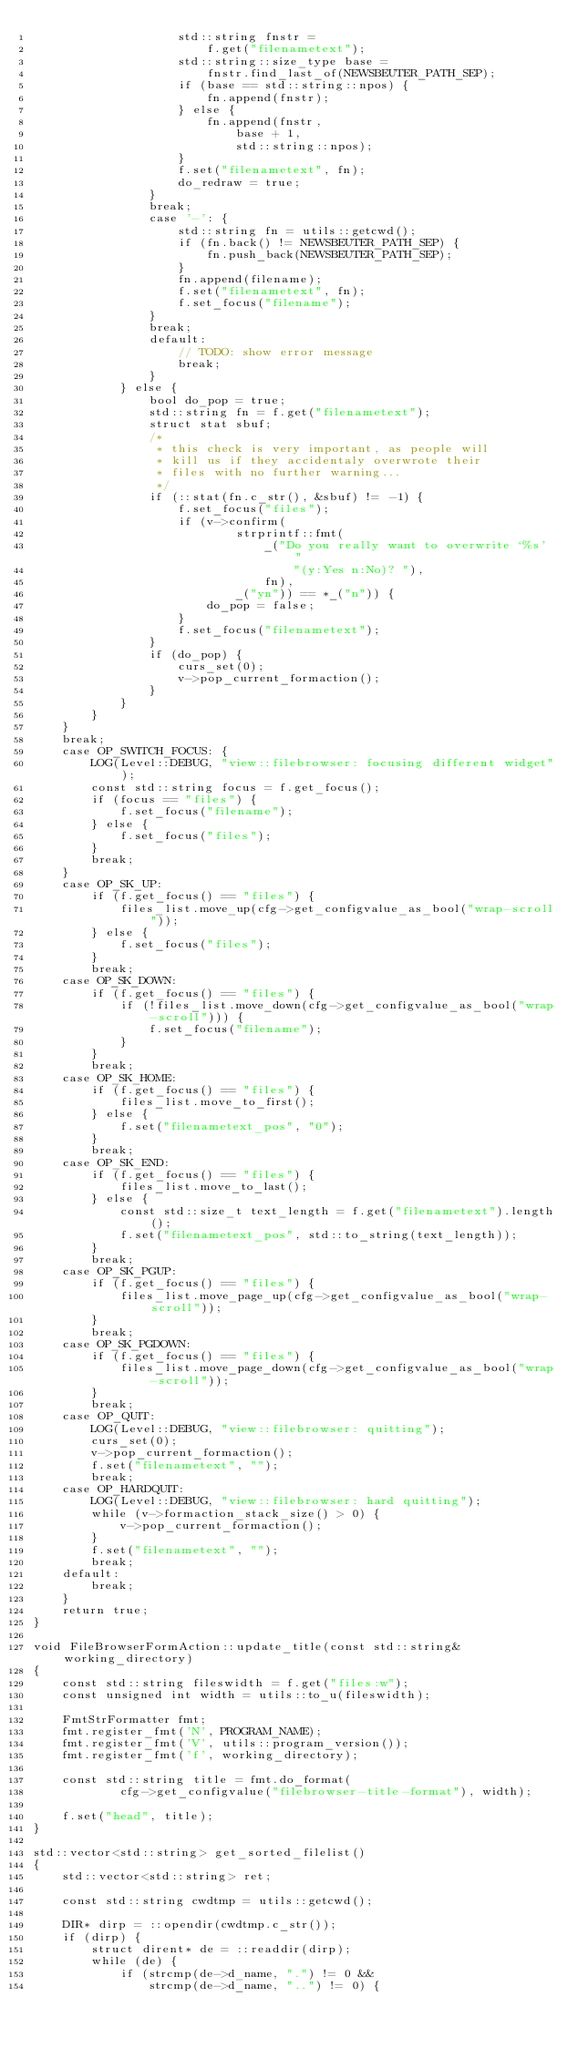<code> <loc_0><loc_0><loc_500><loc_500><_C++_>					std::string fnstr =
						f.get("filenametext");
					std::string::size_type base =
						fnstr.find_last_of(NEWSBEUTER_PATH_SEP);
					if (base == std::string::npos) {
						fn.append(fnstr);
					} else {
						fn.append(fnstr,
							base + 1,
							std::string::npos);
					}
					f.set("filenametext", fn);
					do_redraw = true;
				}
				break;
				case '-': {
					std::string fn = utils::getcwd();
					if (fn.back() != NEWSBEUTER_PATH_SEP) {
						fn.push_back(NEWSBEUTER_PATH_SEP);
					}
					fn.append(filename);
					f.set("filenametext", fn);
					f.set_focus("filename");
				}
				break;
				default:
					// TODO: show error message
					break;
				}
			} else {
				bool do_pop = true;
				std::string fn = f.get("filenametext");
				struct stat sbuf;
				/*
				 * this check is very important, as people will
				 * kill us if they accidentaly overwrote their
				 * files with no further warning...
				 */
				if (::stat(fn.c_str(), &sbuf) != -1) {
					f.set_focus("files");
					if (v->confirm(
							strprintf::fmt(
								_("Do you really want to overwrite `%s' "
									"(y:Yes n:No)? "),
								fn),
							_("yn")) == *_("n")) {
						do_pop = false;
					}
					f.set_focus("filenametext");
				}
				if (do_pop) {
					curs_set(0);
					v->pop_current_formaction();
				}
			}
		}
	}
	break;
	case OP_SWITCH_FOCUS: {
		LOG(Level::DEBUG, "view::filebrowser: focusing different widget");
		const std::string focus = f.get_focus();
		if (focus == "files") {
			f.set_focus("filename");
		} else {
			f.set_focus("files");
		}
		break;
	}
	case OP_SK_UP:
		if (f.get_focus() == "files") {
			files_list.move_up(cfg->get_configvalue_as_bool("wrap-scroll"));
		} else {
			f.set_focus("files");
		}
		break;
	case OP_SK_DOWN:
		if (f.get_focus() == "files") {
			if (!files_list.move_down(cfg->get_configvalue_as_bool("wrap-scroll"))) {
				f.set_focus("filename");
			}
		}
		break;
	case OP_SK_HOME:
		if (f.get_focus() == "files") {
			files_list.move_to_first();
		} else {
			f.set("filenametext_pos", "0");
		}
		break;
	case OP_SK_END:
		if (f.get_focus() == "files") {
			files_list.move_to_last();
		} else {
			const std::size_t text_length = f.get("filenametext").length();
			f.set("filenametext_pos", std::to_string(text_length));
		}
		break;
	case OP_SK_PGUP:
		if (f.get_focus() == "files") {
			files_list.move_page_up(cfg->get_configvalue_as_bool("wrap-scroll"));
		}
		break;
	case OP_SK_PGDOWN:
		if (f.get_focus() == "files") {
			files_list.move_page_down(cfg->get_configvalue_as_bool("wrap-scroll"));
		}
		break;
	case OP_QUIT:
		LOG(Level::DEBUG, "view::filebrowser: quitting");
		curs_set(0);
		v->pop_current_formaction();
		f.set("filenametext", "");
		break;
	case OP_HARDQUIT:
		LOG(Level::DEBUG, "view::filebrowser: hard quitting");
		while (v->formaction_stack_size() > 0) {
			v->pop_current_formaction();
		}
		f.set("filenametext", "");
		break;
	default:
		break;
	}
	return true;
}

void FileBrowserFormAction::update_title(const std::string& working_directory)
{
	const std::string fileswidth = f.get("files:w");
	const unsigned int width = utils::to_u(fileswidth);

	FmtStrFormatter fmt;
	fmt.register_fmt('N', PROGRAM_NAME);
	fmt.register_fmt('V', utils::program_version());
	fmt.register_fmt('f', working_directory);

	const std::string title = fmt.do_format(
			cfg->get_configvalue("filebrowser-title-format"), width);

	f.set("head", title);
}

std::vector<std::string> get_sorted_filelist()
{
	std::vector<std::string> ret;

	const std::string cwdtmp = utils::getcwd();

	DIR* dirp = ::opendir(cwdtmp.c_str());
	if (dirp) {
		struct dirent* de = ::readdir(dirp);
		while (de) {
			if (strcmp(de->d_name, ".") != 0 &&
				strcmp(de->d_name, "..") != 0) {</code> 